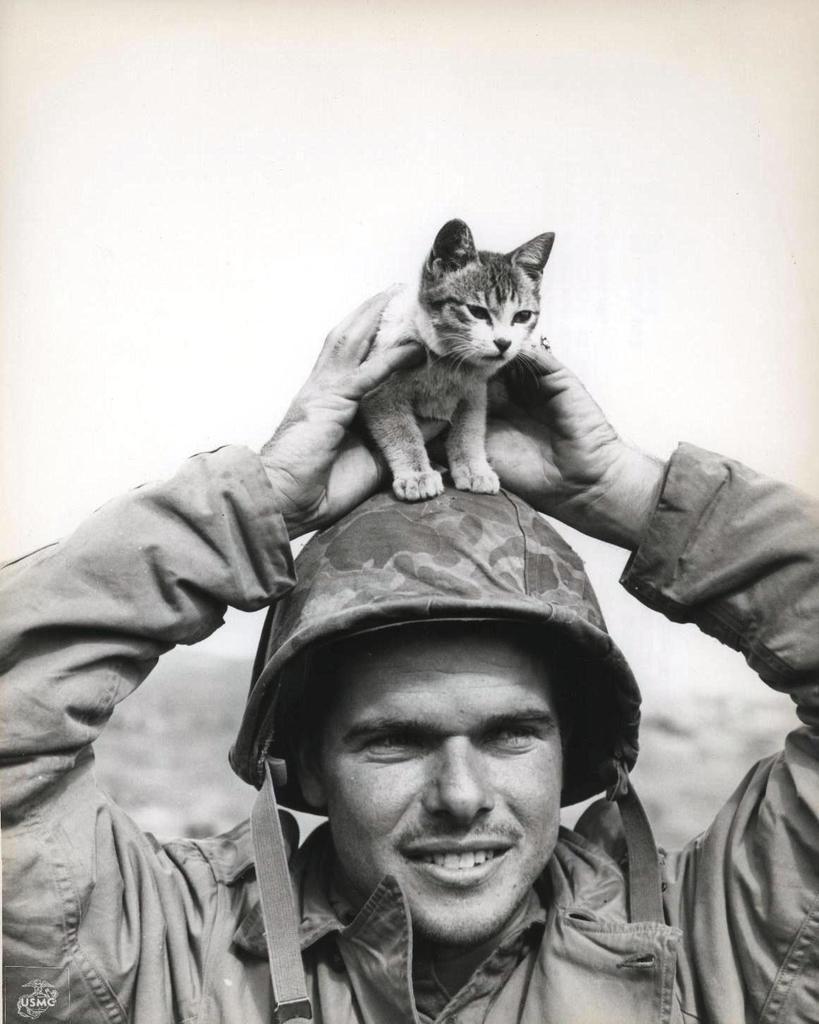What is the person in the image wearing? The person is wearing an army uniform. What type of headgear is the person wearing? The person is wearing a hat. What is the person holding in the image? The person is holding a cat. Where is the cat positioned on the person? The cat is on the person's head. What can be seen in the background of the image? Sky and ground are visible in the background of the image. What type of feather is the person using to act in the image? There is no feather or act present in the image; it features a person wearing an army uniform, wearing a hat, holding a cat on their head, and the background includes sky and ground. 